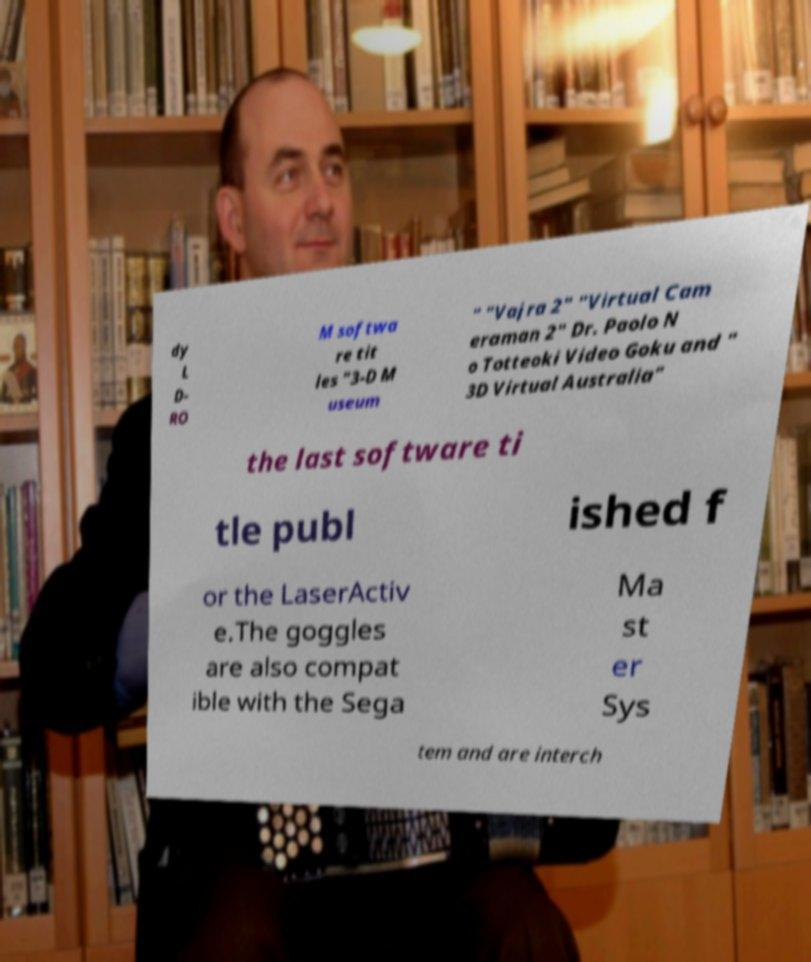Please read and relay the text visible in this image. What does it say? dy L D- RO M softwa re tit les "3-D M useum " "Vajra 2" "Virtual Cam eraman 2" Dr. Paolo N o Totteoki Video Goku and " 3D Virtual Australia" the last software ti tle publ ished f or the LaserActiv e.The goggles are also compat ible with the Sega Ma st er Sys tem and are interch 